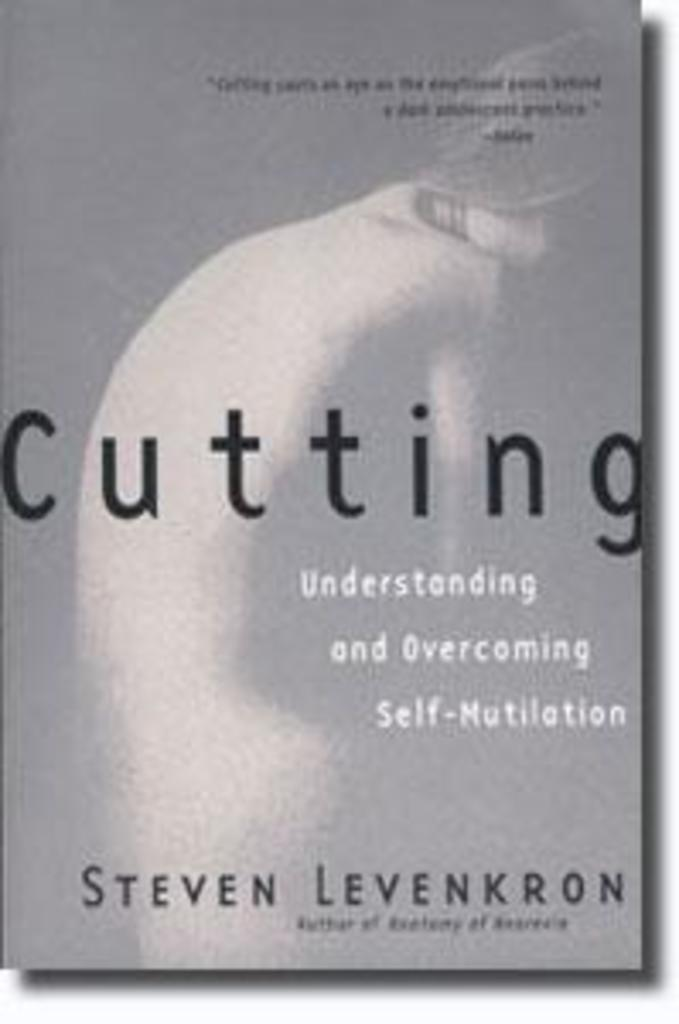<image>
Share a concise interpretation of the image provided. The book cover for the book Cutting by Steven Levenkron. 